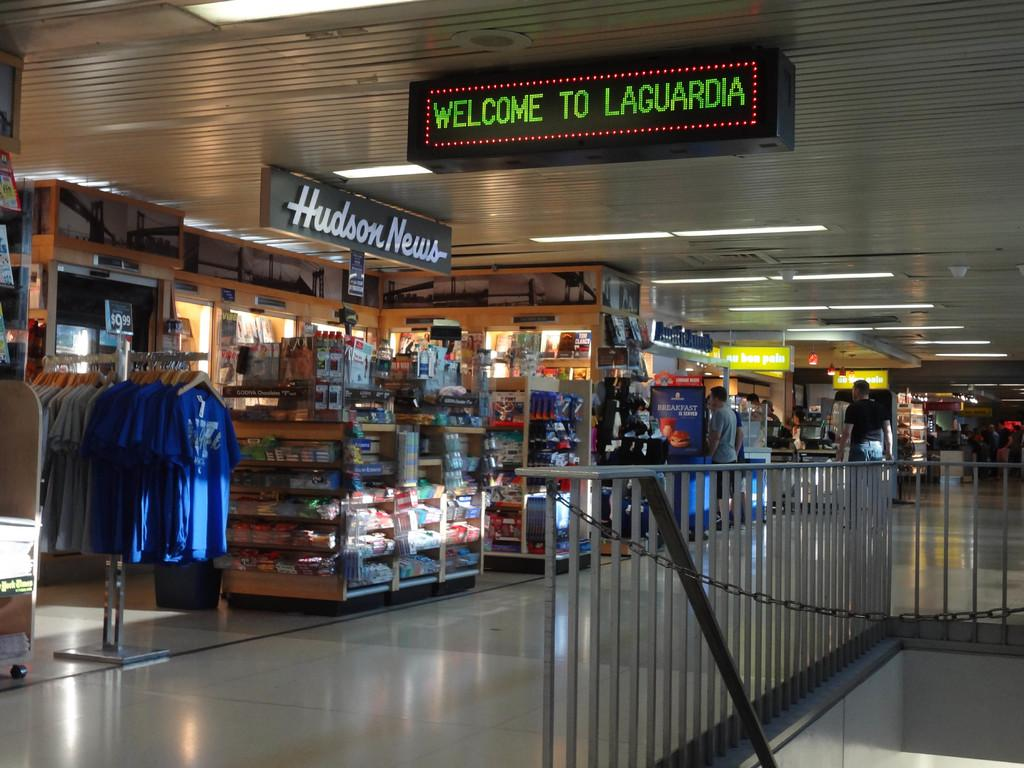Provide a one-sentence caption for the provided image. A sign in front of the Hudson News stand welcomes people to Laguardia airport. 